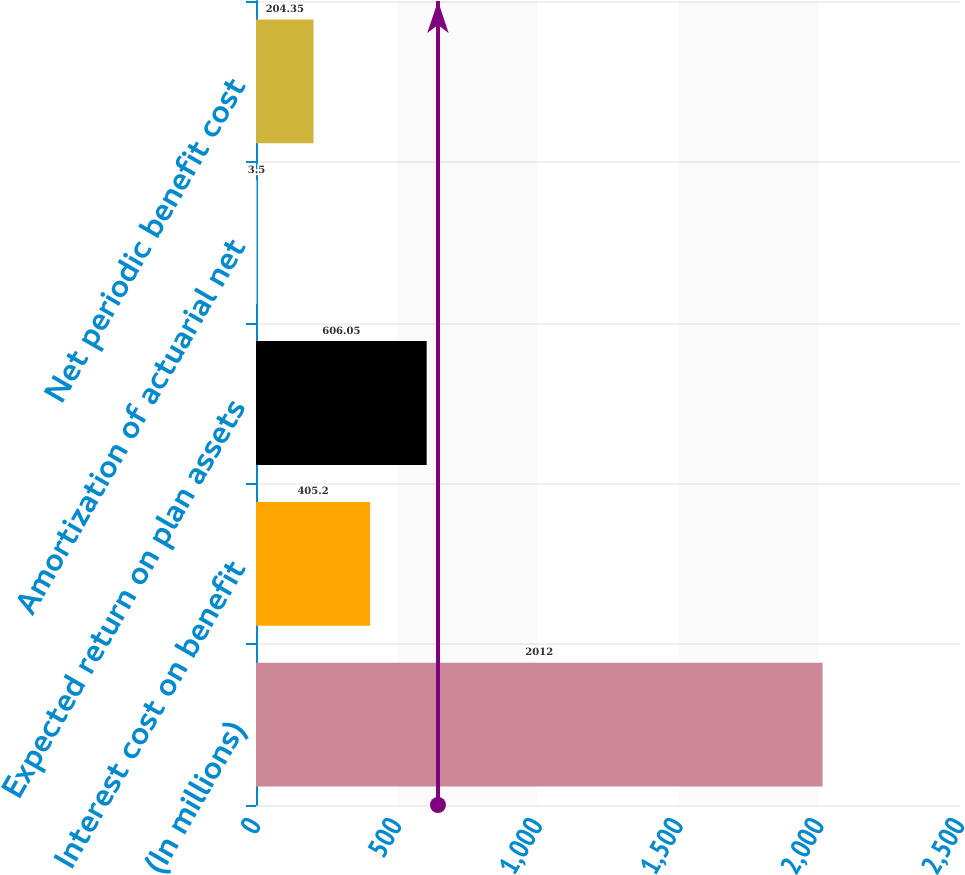<chart> <loc_0><loc_0><loc_500><loc_500><bar_chart><fcel>(In millions)<fcel>Interest cost on benefit<fcel>Expected return on plan assets<fcel>Amortization of actuarial net<fcel>Net periodic benefit cost<nl><fcel>2012<fcel>405.2<fcel>606.05<fcel>3.5<fcel>204.35<nl></chart> 